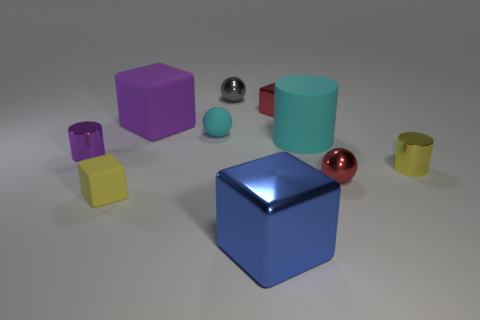Subtract all blue blocks. How many blocks are left? 3 Subtract all yellow cylinders. How many cylinders are left? 2 Subtract 1 blocks. How many blocks are left? 3 Subtract all gray balls. How many cyan cylinders are left? 1 Subtract all tiny brown rubber objects. Subtract all red blocks. How many objects are left? 9 Add 5 yellow cylinders. How many yellow cylinders are left? 6 Add 7 large things. How many large things exist? 10 Subtract 1 yellow cylinders. How many objects are left? 9 Subtract all cubes. How many objects are left? 6 Subtract all cyan blocks. Subtract all cyan cylinders. How many blocks are left? 4 